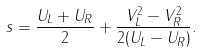Convert formula to latex. <formula><loc_0><loc_0><loc_500><loc_500>s = \frac { U _ { L } + U _ { R } } { 2 } + \frac { V _ { L } ^ { 2 } - V _ { R } ^ { 2 } } { 2 ( U _ { L } - U _ { R } ) } .</formula> 